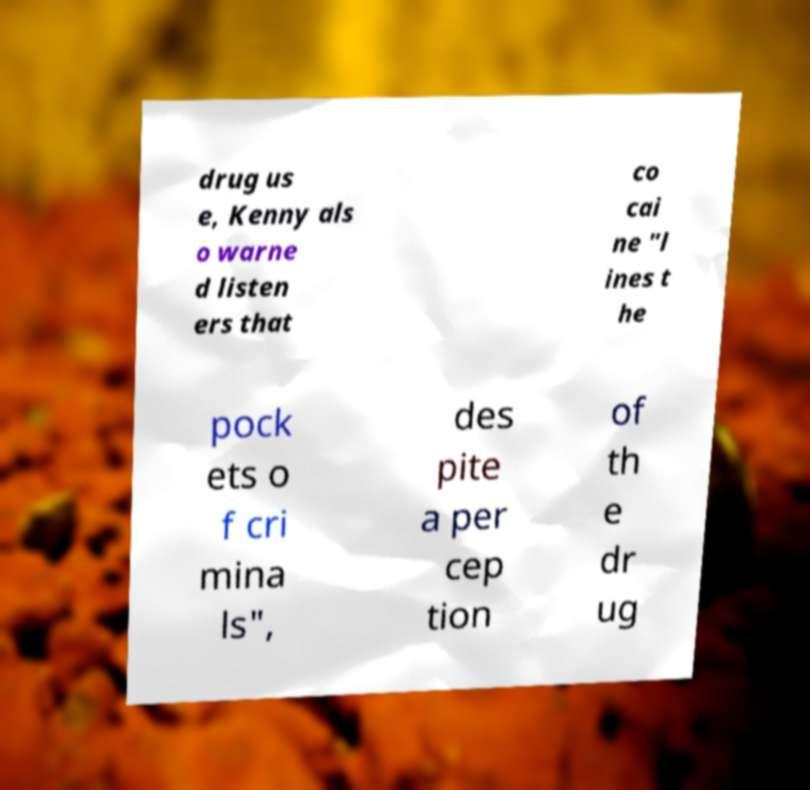Please read and relay the text visible in this image. What does it say? drug us e, Kenny als o warne d listen ers that co cai ne "l ines t he pock ets o f cri mina ls", des pite a per cep tion of th e dr ug 